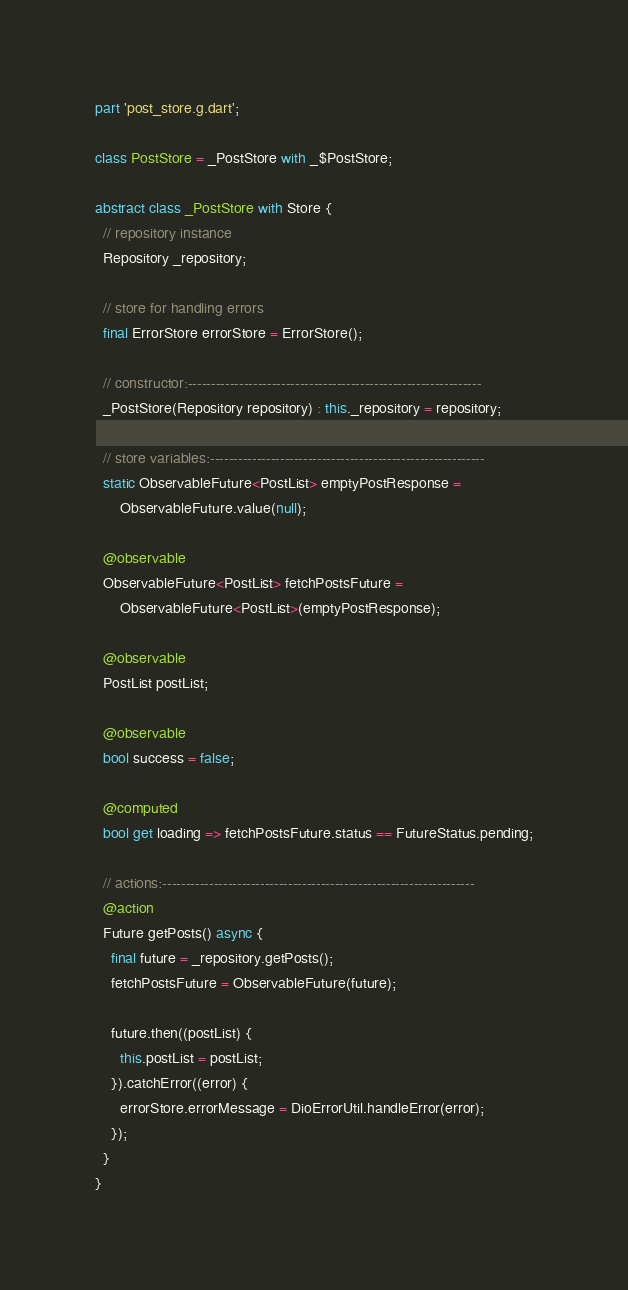<code> <loc_0><loc_0><loc_500><loc_500><_Dart_>part 'post_store.g.dart';

class PostStore = _PostStore with _$PostStore;

abstract class _PostStore with Store {
  // repository instance
  Repository _repository;

  // store for handling errors
  final ErrorStore errorStore = ErrorStore();

  // constructor:---------------------------------------------------------------
  _PostStore(Repository repository) : this._repository = repository;

  // store variables:-----------------------------------------------------------
  static ObservableFuture<PostList> emptyPostResponse =
      ObservableFuture.value(null);

  @observable
  ObservableFuture<PostList> fetchPostsFuture =
      ObservableFuture<PostList>(emptyPostResponse);

  @observable
  PostList postList;

  @observable
  bool success = false;

  @computed
  bool get loading => fetchPostsFuture.status == FutureStatus.pending;

  // actions:-------------------------------------------------------------------
  @action
  Future getPosts() async {
    final future = _repository.getPosts();
    fetchPostsFuture = ObservableFuture(future);

    future.then((postList) {
      this.postList = postList;
    }).catchError((error) {
      errorStore.errorMessage = DioErrorUtil.handleError(error);
    });
  }
}
</code> 